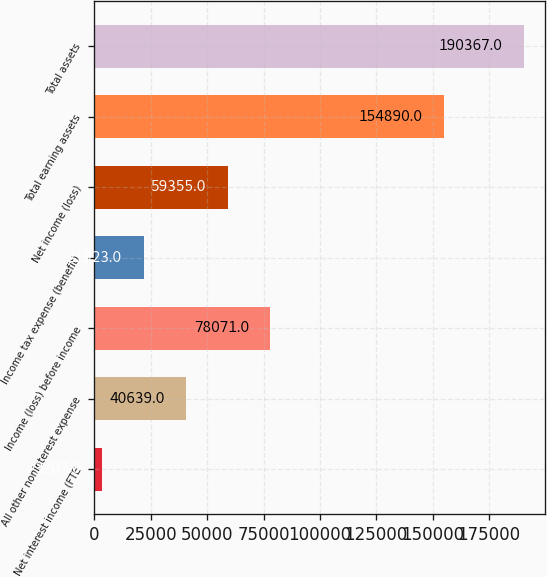<chart> <loc_0><loc_0><loc_500><loc_500><bar_chart><fcel>Net interest income (FTE<fcel>All other noninterest expense<fcel>Income (loss) before income<fcel>Income tax expense (benefit)<fcel>Net income (loss)<fcel>Total earning assets<fcel>Total assets<nl><fcel>3207<fcel>40639<fcel>78071<fcel>21923<fcel>59355<fcel>154890<fcel>190367<nl></chart> 